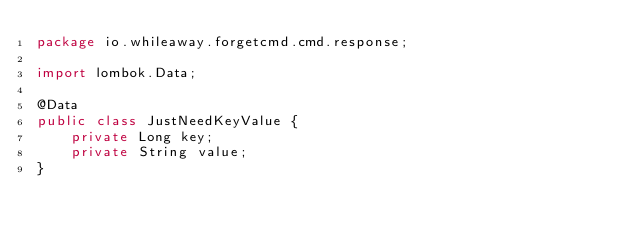<code> <loc_0><loc_0><loc_500><loc_500><_Java_>package io.whileaway.forgetcmd.cmd.response;

import lombok.Data;

@Data
public class JustNeedKeyValue {
    private Long key;
    private String value;
}
</code> 